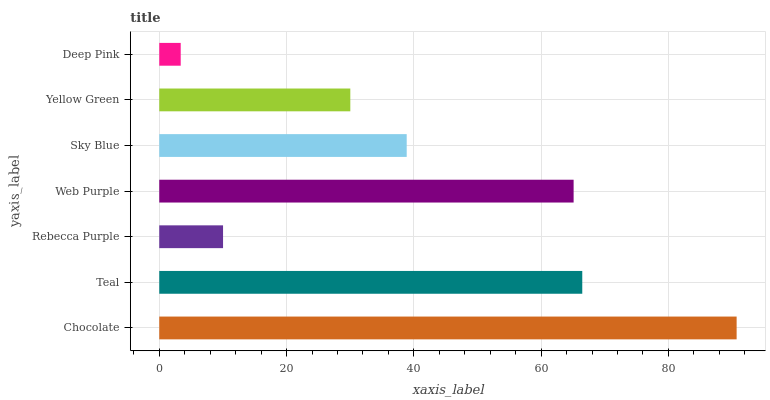Is Deep Pink the minimum?
Answer yes or no. Yes. Is Chocolate the maximum?
Answer yes or no. Yes. Is Teal the minimum?
Answer yes or no. No. Is Teal the maximum?
Answer yes or no. No. Is Chocolate greater than Teal?
Answer yes or no. Yes. Is Teal less than Chocolate?
Answer yes or no. Yes. Is Teal greater than Chocolate?
Answer yes or no. No. Is Chocolate less than Teal?
Answer yes or no. No. Is Sky Blue the high median?
Answer yes or no. Yes. Is Sky Blue the low median?
Answer yes or no. Yes. Is Rebecca Purple the high median?
Answer yes or no. No. Is Web Purple the low median?
Answer yes or no. No. 